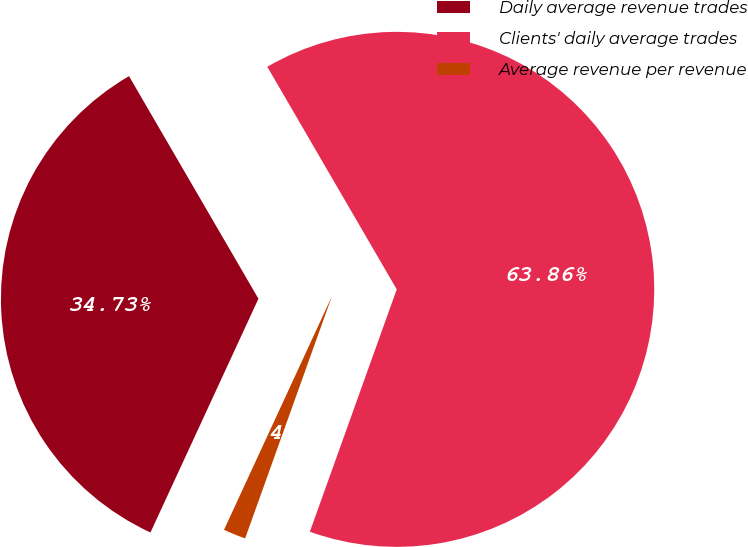<chart> <loc_0><loc_0><loc_500><loc_500><pie_chart><fcel>Daily average revenue trades<fcel>Clients' daily average trades<fcel>Average revenue per revenue<nl><fcel>34.73%<fcel>63.86%<fcel>1.41%<nl></chart> 